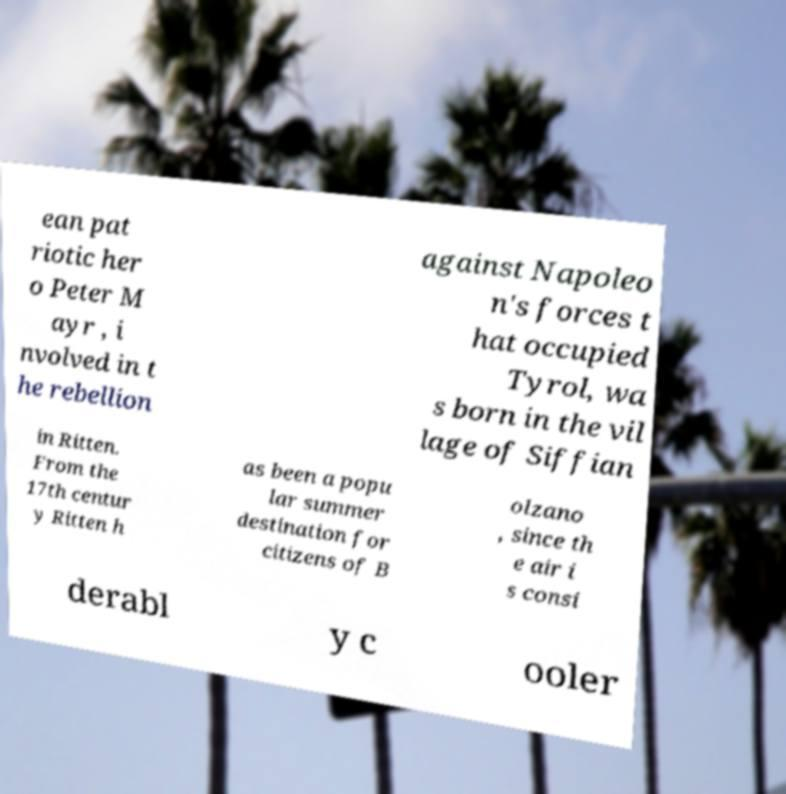Could you assist in decoding the text presented in this image and type it out clearly? ean pat riotic her o Peter M ayr , i nvolved in t he rebellion against Napoleo n's forces t hat occupied Tyrol, wa s born in the vil lage of Siffian in Ritten. From the 17th centur y Ritten h as been a popu lar summer destination for citizens of B olzano , since th e air i s consi derabl y c ooler 